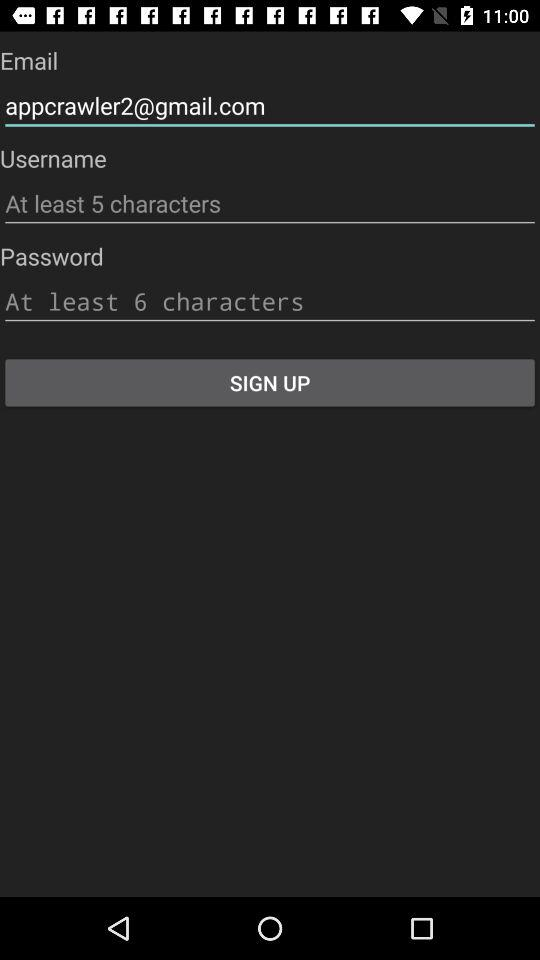What is the email address? The email address is appcrawler2@gmail.com. 